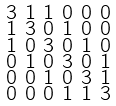Convert formula to latex. <formula><loc_0><loc_0><loc_500><loc_500>\begin{smallmatrix} 3 & 1 & 1 & 0 & 0 & 0 \\ 1 & 3 & 0 & 1 & 0 & 0 \\ 1 & 0 & 3 & 0 & 1 & 0 \\ 0 & 1 & 0 & 3 & 0 & 1 \\ 0 & 0 & 1 & 0 & 3 & 1 \\ 0 & 0 & 0 & 1 & 1 & 3 \end{smallmatrix}</formula> 